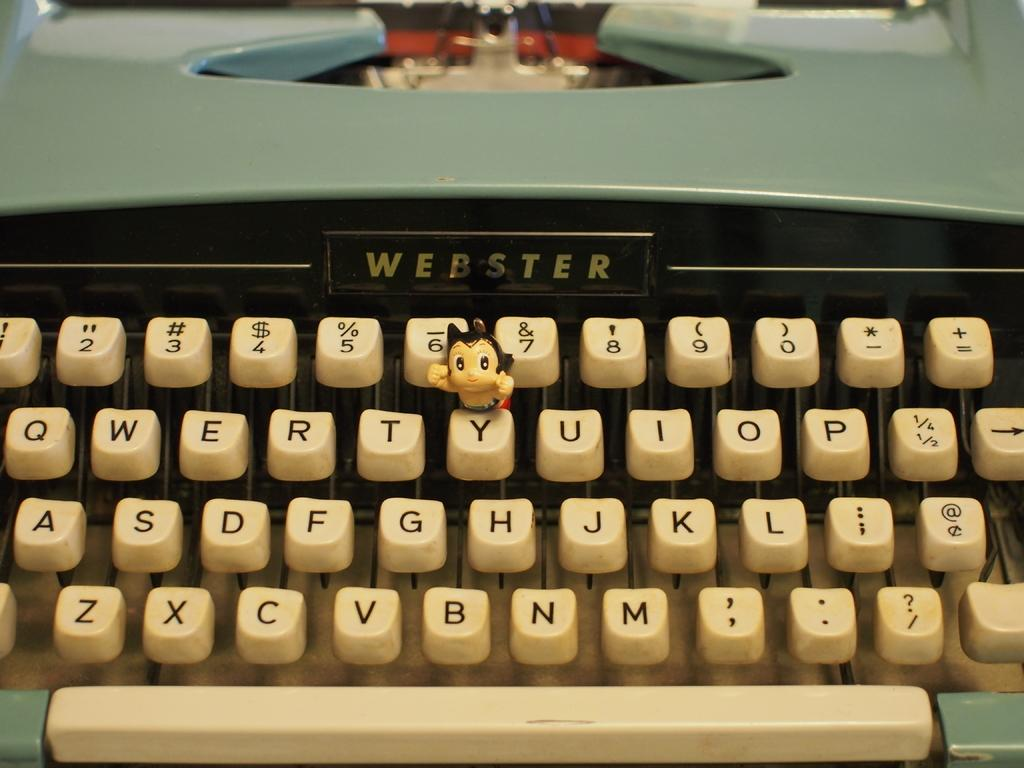<image>
Write a terse but informative summary of the picture. A Webster typewriter with a qwerty key board. 